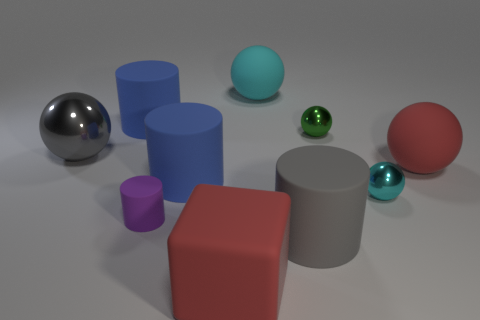What number of cylinders are either purple things or large blue matte things?
Offer a very short reply. 3. There is a matte object that is right of the metal object in front of the large metal ball; what number of objects are behind it?
Keep it short and to the point. 4. The other thing that is the same color as the large metallic thing is what size?
Offer a very short reply. Large. Is there a large blue thing made of the same material as the big gray sphere?
Make the answer very short. No. Does the big gray ball have the same material as the large cyan thing?
Keep it short and to the point. No. There is a rubber cylinder behind the green metallic object; how many big gray cylinders are behind it?
Your response must be concise. 0. What number of blue things are small shiny balls or big matte blocks?
Your response must be concise. 0. There is a gray thing that is behind the metal object in front of the big blue cylinder that is right of the small rubber cylinder; what shape is it?
Your answer should be very brief. Sphere. What color is the shiny ball that is the same size as the matte cube?
Your response must be concise. Gray. How many other large things have the same shape as the green object?
Offer a very short reply. 3. 